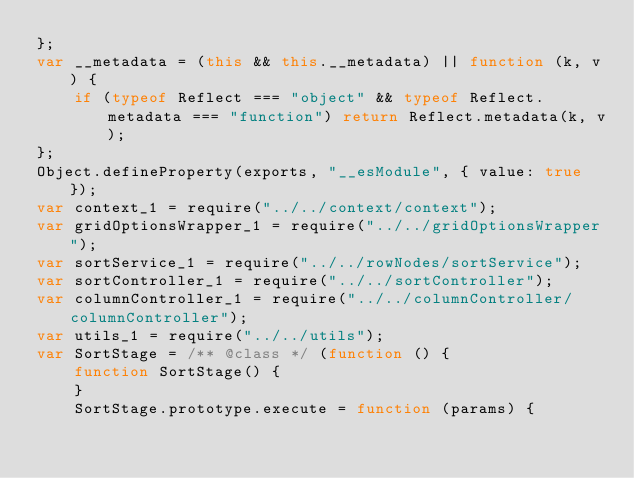<code> <loc_0><loc_0><loc_500><loc_500><_JavaScript_>};
var __metadata = (this && this.__metadata) || function (k, v) {
    if (typeof Reflect === "object" && typeof Reflect.metadata === "function") return Reflect.metadata(k, v);
};
Object.defineProperty(exports, "__esModule", { value: true });
var context_1 = require("../../context/context");
var gridOptionsWrapper_1 = require("../../gridOptionsWrapper");
var sortService_1 = require("../../rowNodes/sortService");
var sortController_1 = require("../../sortController");
var columnController_1 = require("../../columnController/columnController");
var utils_1 = require("../../utils");
var SortStage = /** @class */ (function () {
    function SortStage() {
    }
    SortStage.prototype.execute = function (params) {</code> 